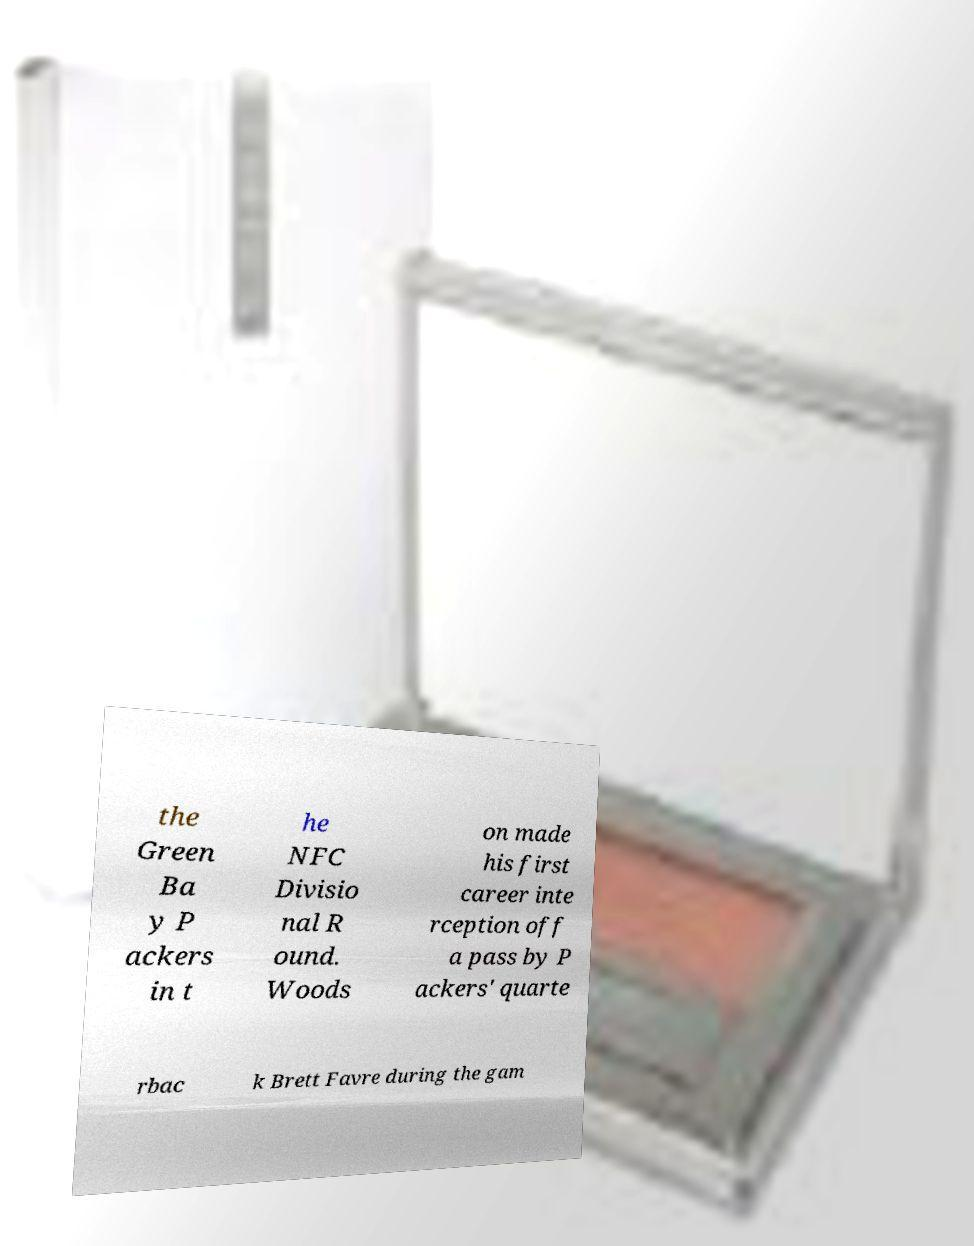Can you accurately transcribe the text from the provided image for me? the Green Ba y P ackers in t he NFC Divisio nal R ound. Woods on made his first career inte rception off a pass by P ackers' quarte rbac k Brett Favre during the gam 